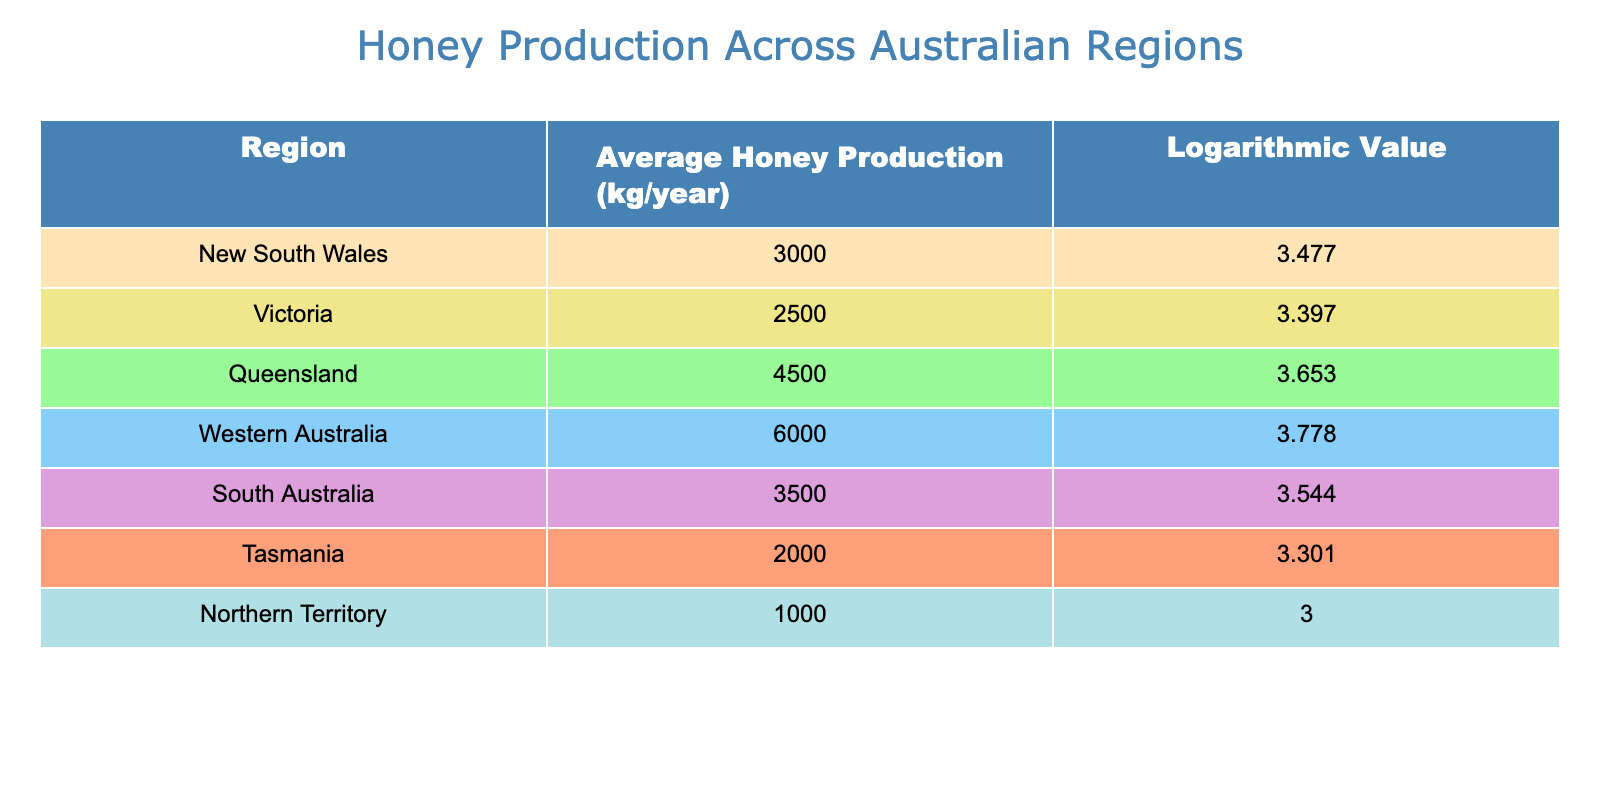What is the average honey production in New South Wales? Referring to the table, the average honey production for New South Wales is listed as 3000 kg/year.
Answer: 3000 kg/year Which region has the highest honey production? According to the table, Western Australia has the highest average honey production at 6000 kg/year.
Answer: Western Australia Calculate the difference in honey production between Queensland and Tasmania. The average honey production in Queensland is 4500 kg/year, while in Tasmania, it is 2000 kg/year. The difference is 4500 - 2000 = 2500 kg/year.
Answer: 2500 kg/year Is the average honey production in Victoria greater than that in South Australia? The average honey production in Victoria is 2500 kg/year and in South Australia, it is 3500 kg/year. Since 2500 is less than 3500, the statement is false.
Answer: No What is the total average honey production for New South Wales and South Australia combined? To find the total, we sum the average honey production of New South Wales (3000 kg/year) and South Australia (3500 kg/year). Therefore, 3000 + 3500 = 6500 kg/year.
Answer: 6500 kg/year Which regions have an average honey production below 3000 kg/year? From the table, only Tasmania (2000 kg/year) and Northern Territory (1000 kg/year) have average honey production below 3000 kg/year.
Answer: Tasmania and Northern Territory Calculate the average honey production across all regions. First, add all the average honey productions: 3000 + 2500 + 4500 + 6000 + 3500 + 2000 + 1000 = 22500 kg/year. Then, divide by the number of regions (7): 22500 / 7 = approximately 3214.29 kg/year.
Answer: Approximately 3214.29 kg/year Is it true that both Queensland and Western Australia have logarithmic values greater than 3.5? The logarithmic values for Queensland and Western Australia are 3.653 and 3.778, respectively, both of which are greater than 3.5. Therefore, the statement is true.
Answer: Yes What is the region with the lowest logarithmic value? The lowest logarithmic value in the table is for the Northern Territory, which is 3.000.
Answer: Northern Territory 